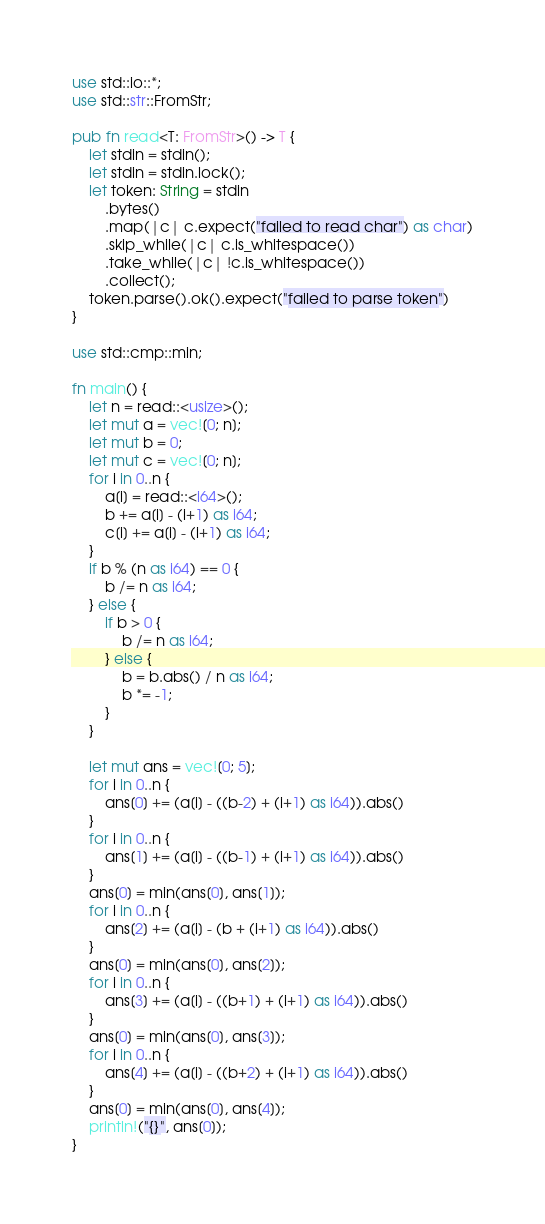Convert code to text. <code><loc_0><loc_0><loc_500><loc_500><_Rust_>use std::io::*;
use std::str::FromStr;

pub fn read<T: FromStr>() -> T {
    let stdin = stdin();
    let stdin = stdin.lock();
    let token: String = stdin
        .bytes()
        .map(|c| c.expect("failed to read char") as char)
        .skip_while(|c| c.is_whitespace())
        .take_while(|c| !c.is_whitespace())
        .collect();
    token.parse().ok().expect("failed to parse token")
}

use std::cmp::min;

fn main() {
    let n = read::<usize>();
    let mut a = vec![0; n];
    let mut b = 0;
    let mut c = vec![0; n];
    for i in 0..n {
        a[i] = read::<i64>();
        b += a[i] - (i+1) as i64;
        c[i] += a[i] - (i+1) as i64;
    }
    if b % (n as i64) == 0 {
        b /= n as i64;
    } else {
        if b > 0 {
            b /= n as i64;
        } else {
            b = b.abs() / n as i64;
            b *= -1;
        }
    }

    let mut ans = vec![0; 5];
    for i in 0..n {
        ans[0] += (a[i] - ((b-2) + (i+1) as i64)).abs()
    }
    for i in 0..n {
        ans[1] += (a[i] - ((b-1) + (i+1) as i64)).abs()
    }
    ans[0] = min(ans[0], ans[1]);
    for i in 0..n {
        ans[2] += (a[i] - (b + (i+1) as i64)).abs()
    }
    ans[0] = min(ans[0], ans[2]);
    for i in 0..n {
        ans[3] += (a[i] - ((b+1) + (i+1) as i64)).abs()
    }
    ans[0] = min(ans[0], ans[3]);
    for i in 0..n {
        ans[4] += (a[i] - ((b+2) + (i+1) as i64)).abs()
    }
    ans[0] = min(ans[0], ans[4]);
    println!("{}", ans[0]);
}</code> 